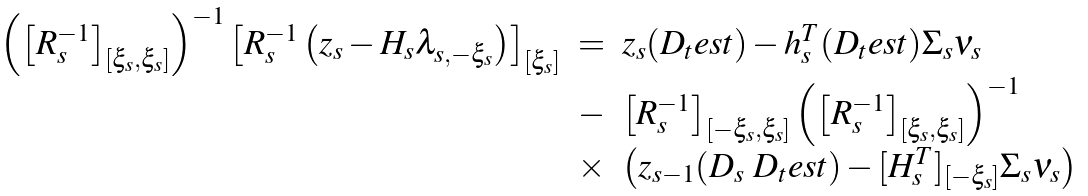<formula> <loc_0><loc_0><loc_500><loc_500>\begin{array} { l l l } \left ( \left [ R _ { s } ^ { - 1 } \right ] _ { [ \xi _ { s } , \xi _ { s } ] } \right ) ^ { - 1 } \left [ R _ { s } ^ { - 1 } \left ( z _ { s } - H _ { s } \lambda _ { s , - \xi _ { s } } \right ) \right ] _ { [ \xi _ { s } ] } & = & z _ { s } ( D _ { t } e s t ) - h _ { s } ^ { T } ( D _ { t } e s t ) \Sigma _ { s } \nu _ { s } \\ & - & \left [ R _ { s } ^ { - 1 } \right ] _ { [ - \xi _ { s } , \xi _ { s } ] } \left ( \left [ R _ { s } ^ { - 1 } \right ] _ { [ \xi _ { s } , \xi _ { s } ] } \right ) ^ { - 1 } \\ & \times & \left ( z _ { s - 1 } ( D _ { s } \ D _ { t } e s t ) - [ H _ { s } ^ { T } ] _ { [ - \xi _ { s } ] } \Sigma _ { s } \nu _ { s } \right ) \end{array}</formula> 